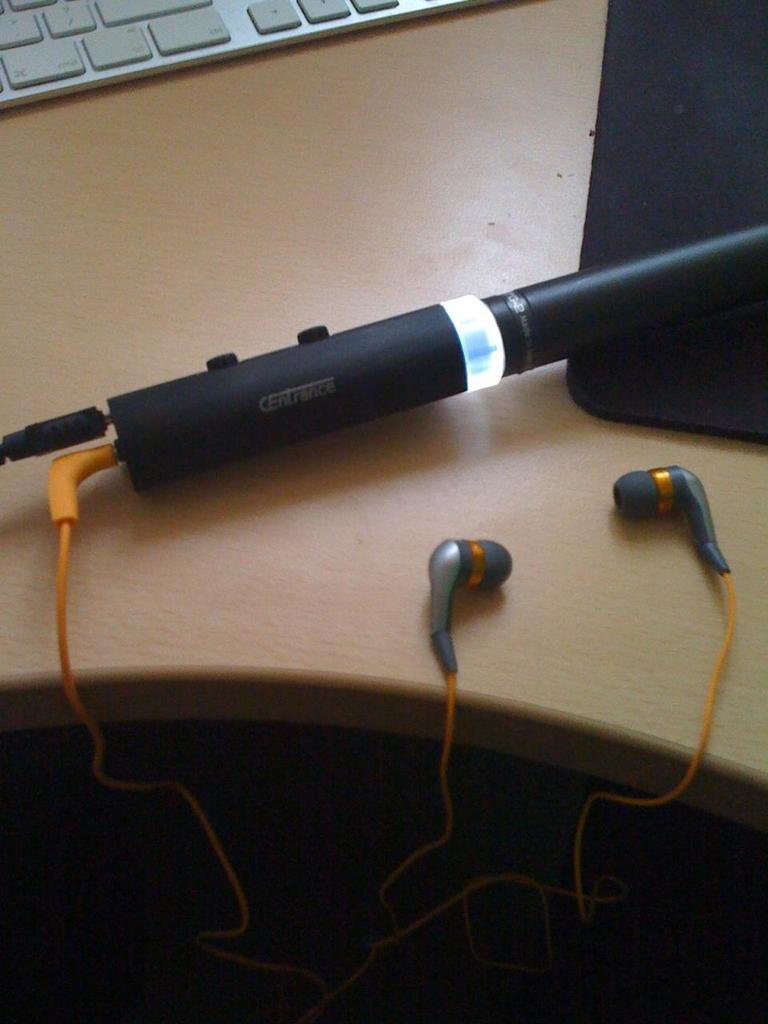What type of furniture is in the image? There is a cream-colored desk in the image. What can be found on the desk? An electronic gadget, earphones, a mouse pad, and a keyboard are visible on the desk. What might be used for input and navigation with the electronic gadget? A keyboard and a mouse pad are on the desk for input and navigation. How many beads are on the desk in the image? There is no mention of beads in the image, so it is not possible to determine their presence or quantity. 